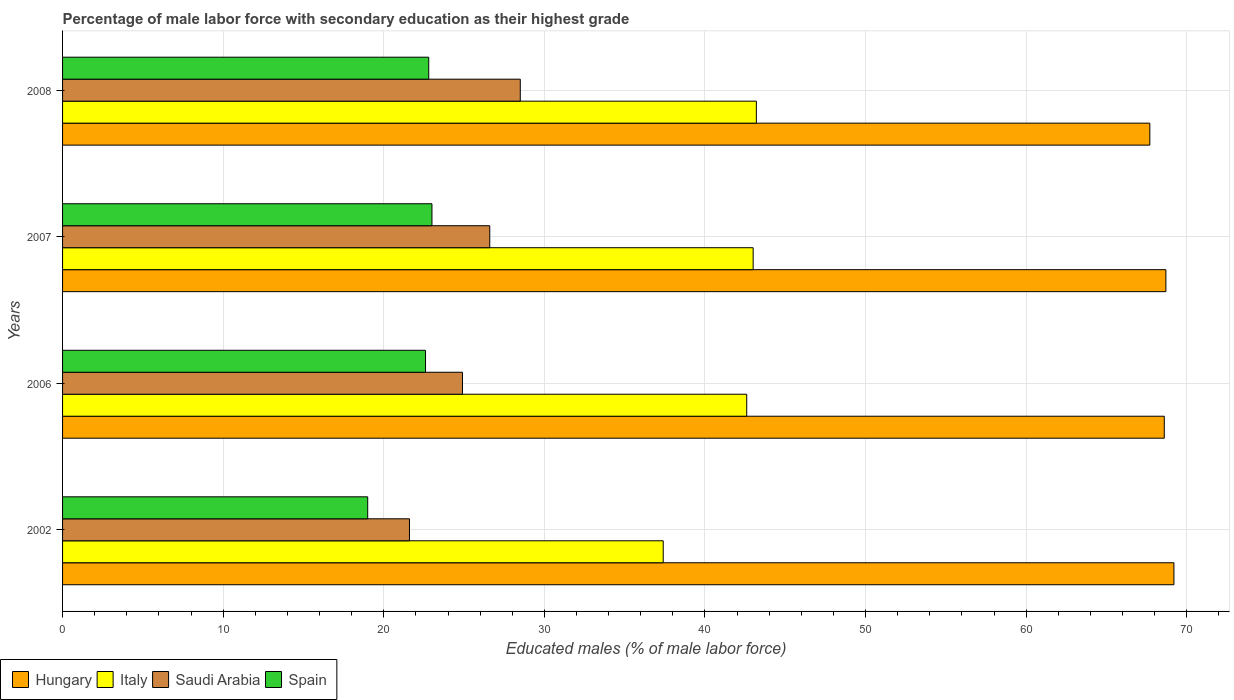Are the number of bars per tick equal to the number of legend labels?
Make the answer very short. Yes. How many bars are there on the 2nd tick from the top?
Give a very brief answer. 4. How many bars are there on the 1st tick from the bottom?
Offer a terse response. 4. What is the label of the 3rd group of bars from the top?
Ensure brevity in your answer.  2006. What is the percentage of male labor force with secondary education in Hungary in 2006?
Ensure brevity in your answer.  68.6. Across all years, what is the maximum percentage of male labor force with secondary education in Italy?
Provide a short and direct response. 43.2. Across all years, what is the minimum percentage of male labor force with secondary education in Saudi Arabia?
Make the answer very short. 21.6. In which year was the percentage of male labor force with secondary education in Saudi Arabia minimum?
Give a very brief answer. 2002. What is the total percentage of male labor force with secondary education in Saudi Arabia in the graph?
Ensure brevity in your answer.  101.6. What is the difference between the percentage of male labor force with secondary education in Saudi Arabia in 2002 and that in 2006?
Provide a short and direct response. -3.3. What is the average percentage of male labor force with secondary education in Saudi Arabia per year?
Your response must be concise. 25.4. In the year 2002, what is the difference between the percentage of male labor force with secondary education in Italy and percentage of male labor force with secondary education in Spain?
Your answer should be compact. 18.4. In how many years, is the percentage of male labor force with secondary education in Spain greater than 52 %?
Keep it short and to the point. 0. What is the ratio of the percentage of male labor force with secondary education in Italy in 2002 to that in 2006?
Provide a succinct answer. 0.88. Is the difference between the percentage of male labor force with secondary education in Italy in 2006 and 2007 greater than the difference between the percentage of male labor force with secondary education in Spain in 2006 and 2007?
Make the answer very short. No. What is the difference between the highest and the second highest percentage of male labor force with secondary education in Saudi Arabia?
Make the answer very short. 1.9. What is the difference between the highest and the lowest percentage of male labor force with secondary education in Saudi Arabia?
Provide a short and direct response. 6.9. In how many years, is the percentage of male labor force with secondary education in Spain greater than the average percentage of male labor force with secondary education in Spain taken over all years?
Your answer should be compact. 3. Is the sum of the percentage of male labor force with secondary education in Hungary in 2006 and 2008 greater than the maximum percentage of male labor force with secondary education in Saudi Arabia across all years?
Your answer should be very brief. Yes. What does the 2nd bar from the bottom in 2006 represents?
Ensure brevity in your answer.  Italy. How many bars are there?
Your answer should be very brief. 16. Are all the bars in the graph horizontal?
Keep it short and to the point. Yes. What is the difference between two consecutive major ticks on the X-axis?
Your answer should be very brief. 10. Are the values on the major ticks of X-axis written in scientific E-notation?
Your answer should be compact. No. Does the graph contain any zero values?
Give a very brief answer. No. Where does the legend appear in the graph?
Provide a short and direct response. Bottom left. How many legend labels are there?
Keep it short and to the point. 4. How are the legend labels stacked?
Your answer should be compact. Horizontal. What is the title of the graph?
Give a very brief answer. Percentage of male labor force with secondary education as their highest grade. What is the label or title of the X-axis?
Your answer should be very brief. Educated males (% of male labor force). What is the label or title of the Y-axis?
Your response must be concise. Years. What is the Educated males (% of male labor force) in Hungary in 2002?
Keep it short and to the point. 69.2. What is the Educated males (% of male labor force) of Italy in 2002?
Provide a succinct answer. 37.4. What is the Educated males (% of male labor force) in Saudi Arabia in 2002?
Keep it short and to the point. 21.6. What is the Educated males (% of male labor force) in Hungary in 2006?
Offer a terse response. 68.6. What is the Educated males (% of male labor force) of Italy in 2006?
Offer a very short reply. 42.6. What is the Educated males (% of male labor force) in Saudi Arabia in 2006?
Offer a terse response. 24.9. What is the Educated males (% of male labor force) of Spain in 2006?
Offer a terse response. 22.6. What is the Educated males (% of male labor force) in Hungary in 2007?
Your response must be concise. 68.7. What is the Educated males (% of male labor force) of Saudi Arabia in 2007?
Provide a succinct answer. 26.6. What is the Educated males (% of male labor force) in Spain in 2007?
Your answer should be very brief. 23. What is the Educated males (% of male labor force) in Hungary in 2008?
Your answer should be compact. 67.7. What is the Educated males (% of male labor force) of Italy in 2008?
Keep it short and to the point. 43.2. What is the Educated males (% of male labor force) in Spain in 2008?
Provide a short and direct response. 22.8. Across all years, what is the maximum Educated males (% of male labor force) of Hungary?
Your response must be concise. 69.2. Across all years, what is the maximum Educated males (% of male labor force) in Italy?
Make the answer very short. 43.2. Across all years, what is the maximum Educated males (% of male labor force) in Saudi Arabia?
Your answer should be compact. 28.5. Across all years, what is the maximum Educated males (% of male labor force) of Spain?
Give a very brief answer. 23. Across all years, what is the minimum Educated males (% of male labor force) of Hungary?
Your response must be concise. 67.7. Across all years, what is the minimum Educated males (% of male labor force) in Italy?
Your response must be concise. 37.4. Across all years, what is the minimum Educated males (% of male labor force) of Saudi Arabia?
Offer a terse response. 21.6. Across all years, what is the minimum Educated males (% of male labor force) in Spain?
Provide a short and direct response. 19. What is the total Educated males (% of male labor force) of Hungary in the graph?
Your answer should be compact. 274.2. What is the total Educated males (% of male labor force) in Italy in the graph?
Ensure brevity in your answer.  166.2. What is the total Educated males (% of male labor force) in Saudi Arabia in the graph?
Your answer should be very brief. 101.6. What is the total Educated males (% of male labor force) in Spain in the graph?
Your answer should be very brief. 87.4. What is the difference between the Educated males (% of male labor force) in Saudi Arabia in 2002 and that in 2006?
Offer a terse response. -3.3. What is the difference between the Educated males (% of male labor force) of Spain in 2002 and that in 2006?
Ensure brevity in your answer.  -3.6. What is the difference between the Educated males (% of male labor force) in Hungary in 2002 and that in 2007?
Offer a terse response. 0.5. What is the difference between the Educated males (% of male labor force) of Italy in 2002 and that in 2007?
Offer a terse response. -5.6. What is the difference between the Educated males (% of male labor force) of Saudi Arabia in 2002 and that in 2007?
Offer a very short reply. -5. What is the difference between the Educated males (% of male labor force) in Spain in 2002 and that in 2008?
Keep it short and to the point. -3.8. What is the difference between the Educated males (% of male labor force) of Hungary in 2006 and that in 2007?
Make the answer very short. -0.1. What is the difference between the Educated males (% of male labor force) in Saudi Arabia in 2006 and that in 2007?
Offer a very short reply. -1.7. What is the difference between the Educated males (% of male labor force) in Spain in 2006 and that in 2007?
Offer a very short reply. -0.4. What is the difference between the Educated males (% of male labor force) in Hungary in 2006 and that in 2008?
Give a very brief answer. 0.9. What is the difference between the Educated males (% of male labor force) in Saudi Arabia in 2007 and that in 2008?
Ensure brevity in your answer.  -1.9. What is the difference between the Educated males (% of male labor force) in Hungary in 2002 and the Educated males (% of male labor force) in Italy in 2006?
Provide a short and direct response. 26.6. What is the difference between the Educated males (% of male labor force) in Hungary in 2002 and the Educated males (% of male labor force) in Saudi Arabia in 2006?
Your response must be concise. 44.3. What is the difference between the Educated males (% of male labor force) of Hungary in 2002 and the Educated males (% of male labor force) of Spain in 2006?
Give a very brief answer. 46.6. What is the difference between the Educated males (% of male labor force) in Italy in 2002 and the Educated males (% of male labor force) in Saudi Arabia in 2006?
Your answer should be very brief. 12.5. What is the difference between the Educated males (% of male labor force) of Italy in 2002 and the Educated males (% of male labor force) of Spain in 2006?
Give a very brief answer. 14.8. What is the difference between the Educated males (% of male labor force) of Hungary in 2002 and the Educated males (% of male labor force) of Italy in 2007?
Provide a succinct answer. 26.2. What is the difference between the Educated males (% of male labor force) of Hungary in 2002 and the Educated males (% of male labor force) of Saudi Arabia in 2007?
Ensure brevity in your answer.  42.6. What is the difference between the Educated males (% of male labor force) of Hungary in 2002 and the Educated males (% of male labor force) of Spain in 2007?
Provide a short and direct response. 46.2. What is the difference between the Educated males (% of male labor force) of Italy in 2002 and the Educated males (% of male labor force) of Saudi Arabia in 2007?
Keep it short and to the point. 10.8. What is the difference between the Educated males (% of male labor force) of Hungary in 2002 and the Educated males (% of male labor force) of Italy in 2008?
Provide a succinct answer. 26. What is the difference between the Educated males (% of male labor force) in Hungary in 2002 and the Educated males (% of male labor force) in Saudi Arabia in 2008?
Your answer should be very brief. 40.7. What is the difference between the Educated males (% of male labor force) of Hungary in 2002 and the Educated males (% of male labor force) of Spain in 2008?
Offer a very short reply. 46.4. What is the difference between the Educated males (% of male labor force) in Italy in 2002 and the Educated males (% of male labor force) in Saudi Arabia in 2008?
Offer a very short reply. 8.9. What is the difference between the Educated males (% of male labor force) in Italy in 2002 and the Educated males (% of male labor force) in Spain in 2008?
Your answer should be compact. 14.6. What is the difference between the Educated males (% of male labor force) in Hungary in 2006 and the Educated males (% of male labor force) in Italy in 2007?
Your answer should be very brief. 25.6. What is the difference between the Educated males (% of male labor force) in Hungary in 2006 and the Educated males (% of male labor force) in Spain in 2007?
Ensure brevity in your answer.  45.6. What is the difference between the Educated males (% of male labor force) of Italy in 2006 and the Educated males (% of male labor force) of Spain in 2007?
Keep it short and to the point. 19.6. What is the difference between the Educated males (% of male labor force) in Saudi Arabia in 2006 and the Educated males (% of male labor force) in Spain in 2007?
Offer a terse response. 1.9. What is the difference between the Educated males (% of male labor force) in Hungary in 2006 and the Educated males (% of male labor force) in Italy in 2008?
Ensure brevity in your answer.  25.4. What is the difference between the Educated males (% of male labor force) of Hungary in 2006 and the Educated males (% of male labor force) of Saudi Arabia in 2008?
Provide a succinct answer. 40.1. What is the difference between the Educated males (% of male labor force) of Hungary in 2006 and the Educated males (% of male labor force) of Spain in 2008?
Ensure brevity in your answer.  45.8. What is the difference between the Educated males (% of male labor force) in Italy in 2006 and the Educated males (% of male labor force) in Spain in 2008?
Keep it short and to the point. 19.8. What is the difference between the Educated males (% of male labor force) in Hungary in 2007 and the Educated males (% of male labor force) in Italy in 2008?
Your answer should be very brief. 25.5. What is the difference between the Educated males (% of male labor force) of Hungary in 2007 and the Educated males (% of male labor force) of Saudi Arabia in 2008?
Your answer should be very brief. 40.2. What is the difference between the Educated males (% of male labor force) of Hungary in 2007 and the Educated males (% of male labor force) of Spain in 2008?
Your answer should be compact. 45.9. What is the difference between the Educated males (% of male labor force) of Italy in 2007 and the Educated males (% of male labor force) of Saudi Arabia in 2008?
Your answer should be compact. 14.5. What is the difference between the Educated males (% of male labor force) in Italy in 2007 and the Educated males (% of male labor force) in Spain in 2008?
Keep it short and to the point. 20.2. What is the difference between the Educated males (% of male labor force) of Saudi Arabia in 2007 and the Educated males (% of male labor force) of Spain in 2008?
Make the answer very short. 3.8. What is the average Educated males (% of male labor force) of Hungary per year?
Make the answer very short. 68.55. What is the average Educated males (% of male labor force) in Italy per year?
Ensure brevity in your answer.  41.55. What is the average Educated males (% of male labor force) in Saudi Arabia per year?
Keep it short and to the point. 25.4. What is the average Educated males (% of male labor force) of Spain per year?
Provide a short and direct response. 21.85. In the year 2002, what is the difference between the Educated males (% of male labor force) of Hungary and Educated males (% of male labor force) of Italy?
Your response must be concise. 31.8. In the year 2002, what is the difference between the Educated males (% of male labor force) in Hungary and Educated males (% of male labor force) in Saudi Arabia?
Provide a short and direct response. 47.6. In the year 2002, what is the difference between the Educated males (% of male labor force) in Hungary and Educated males (% of male labor force) in Spain?
Your answer should be compact. 50.2. In the year 2002, what is the difference between the Educated males (% of male labor force) in Saudi Arabia and Educated males (% of male labor force) in Spain?
Offer a terse response. 2.6. In the year 2006, what is the difference between the Educated males (% of male labor force) of Hungary and Educated males (% of male labor force) of Italy?
Give a very brief answer. 26. In the year 2006, what is the difference between the Educated males (% of male labor force) in Hungary and Educated males (% of male labor force) in Saudi Arabia?
Offer a very short reply. 43.7. In the year 2006, what is the difference between the Educated males (% of male labor force) of Hungary and Educated males (% of male labor force) of Spain?
Give a very brief answer. 46. In the year 2006, what is the difference between the Educated males (% of male labor force) of Italy and Educated males (% of male labor force) of Spain?
Ensure brevity in your answer.  20. In the year 2007, what is the difference between the Educated males (% of male labor force) in Hungary and Educated males (% of male labor force) in Italy?
Provide a short and direct response. 25.7. In the year 2007, what is the difference between the Educated males (% of male labor force) of Hungary and Educated males (% of male labor force) of Saudi Arabia?
Your answer should be compact. 42.1. In the year 2007, what is the difference between the Educated males (% of male labor force) in Hungary and Educated males (% of male labor force) in Spain?
Ensure brevity in your answer.  45.7. In the year 2007, what is the difference between the Educated males (% of male labor force) in Italy and Educated males (% of male labor force) in Saudi Arabia?
Keep it short and to the point. 16.4. In the year 2007, what is the difference between the Educated males (% of male labor force) of Saudi Arabia and Educated males (% of male labor force) of Spain?
Keep it short and to the point. 3.6. In the year 2008, what is the difference between the Educated males (% of male labor force) in Hungary and Educated males (% of male labor force) in Saudi Arabia?
Offer a terse response. 39.2. In the year 2008, what is the difference between the Educated males (% of male labor force) in Hungary and Educated males (% of male labor force) in Spain?
Provide a short and direct response. 44.9. In the year 2008, what is the difference between the Educated males (% of male labor force) in Italy and Educated males (% of male labor force) in Spain?
Offer a very short reply. 20.4. What is the ratio of the Educated males (% of male labor force) of Hungary in 2002 to that in 2006?
Your answer should be very brief. 1.01. What is the ratio of the Educated males (% of male labor force) of Italy in 2002 to that in 2006?
Give a very brief answer. 0.88. What is the ratio of the Educated males (% of male labor force) of Saudi Arabia in 2002 to that in 2006?
Your response must be concise. 0.87. What is the ratio of the Educated males (% of male labor force) in Spain in 2002 to that in 2006?
Give a very brief answer. 0.84. What is the ratio of the Educated males (% of male labor force) in Hungary in 2002 to that in 2007?
Make the answer very short. 1.01. What is the ratio of the Educated males (% of male labor force) in Italy in 2002 to that in 2007?
Give a very brief answer. 0.87. What is the ratio of the Educated males (% of male labor force) in Saudi Arabia in 2002 to that in 2007?
Keep it short and to the point. 0.81. What is the ratio of the Educated males (% of male labor force) in Spain in 2002 to that in 2007?
Your answer should be compact. 0.83. What is the ratio of the Educated males (% of male labor force) of Hungary in 2002 to that in 2008?
Your answer should be compact. 1.02. What is the ratio of the Educated males (% of male labor force) in Italy in 2002 to that in 2008?
Give a very brief answer. 0.87. What is the ratio of the Educated males (% of male labor force) of Saudi Arabia in 2002 to that in 2008?
Provide a short and direct response. 0.76. What is the ratio of the Educated males (% of male labor force) of Italy in 2006 to that in 2007?
Provide a short and direct response. 0.99. What is the ratio of the Educated males (% of male labor force) of Saudi Arabia in 2006 to that in 2007?
Offer a very short reply. 0.94. What is the ratio of the Educated males (% of male labor force) of Spain in 2006 to that in 2007?
Offer a very short reply. 0.98. What is the ratio of the Educated males (% of male labor force) in Hungary in 2006 to that in 2008?
Make the answer very short. 1.01. What is the ratio of the Educated males (% of male labor force) in Italy in 2006 to that in 2008?
Your response must be concise. 0.99. What is the ratio of the Educated males (% of male labor force) in Saudi Arabia in 2006 to that in 2008?
Your answer should be compact. 0.87. What is the ratio of the Educated males (% of male labor force) of Spain in 2006 to that in 2008?
Provide a succinct answer. 0.99. What is the ratio of the Educated males (% of male labor force) of Hungary in 2007 to that in 2008?
Give a very brief answer. 1.01. What is the ratio of the Educated males (% of male labor force) of Saudi Arabia in 2007 to that in 2008?
Make the answer very short. 0.93. What is the ratio of the Educated males (% of male labor force) of Spain in 2007 to that in 2008?
Give a very brief answer. 1.01. What is the difference between the highest and the second highest Educated males (% of male labor force) in Italy?
Offer a terse response. 0.2. What is the difference between the highest and the second highest Educated males (% of male labor force) of Saudi Arabia?
Offer a very short reply. 1.9. What is the difference between the highest and the second highest Educated males (% of male labor force) of Spain?
Offer a terse response. 0.2. What is the difference between the highest and the lowest Educated males (% of male labor force) of Hungary?
Provide a succinct answer. 1.5. What is the difference between the highest and the lowest Educated males (% of male labor force) in Saudi Arabia?
Provide a short and direct response. 6.9. What is the difference between the highest and the lowest Educated males (% of male labor force) of Spain?
Your answer should be compact. 4. 